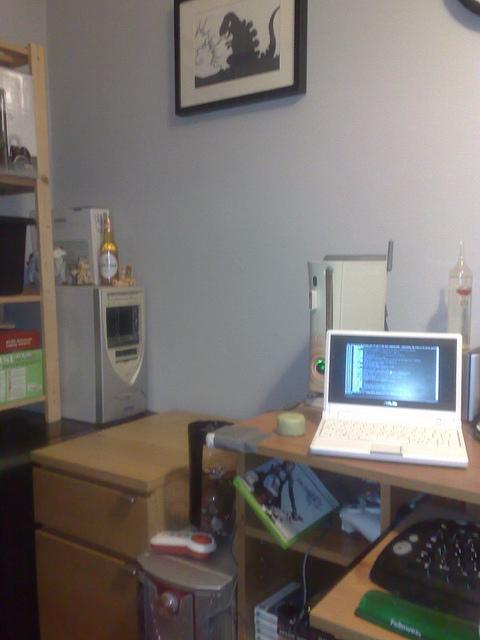How many pictures are on the wall?
Give a very brief answer. 1. How many computer screens are on?
Give a very brief answer. 1. How many keyboards are they?
Give a very brief answer. 2. How many computers are in the room?
Give a very brief answer. 1. How many monitors are on?
Give a very brief answer. 1. How many keyboards can be seen?
Give a very brief answer. 2. How many feet does the girl have on the skateboard?
Give a very brief answer. 0. 